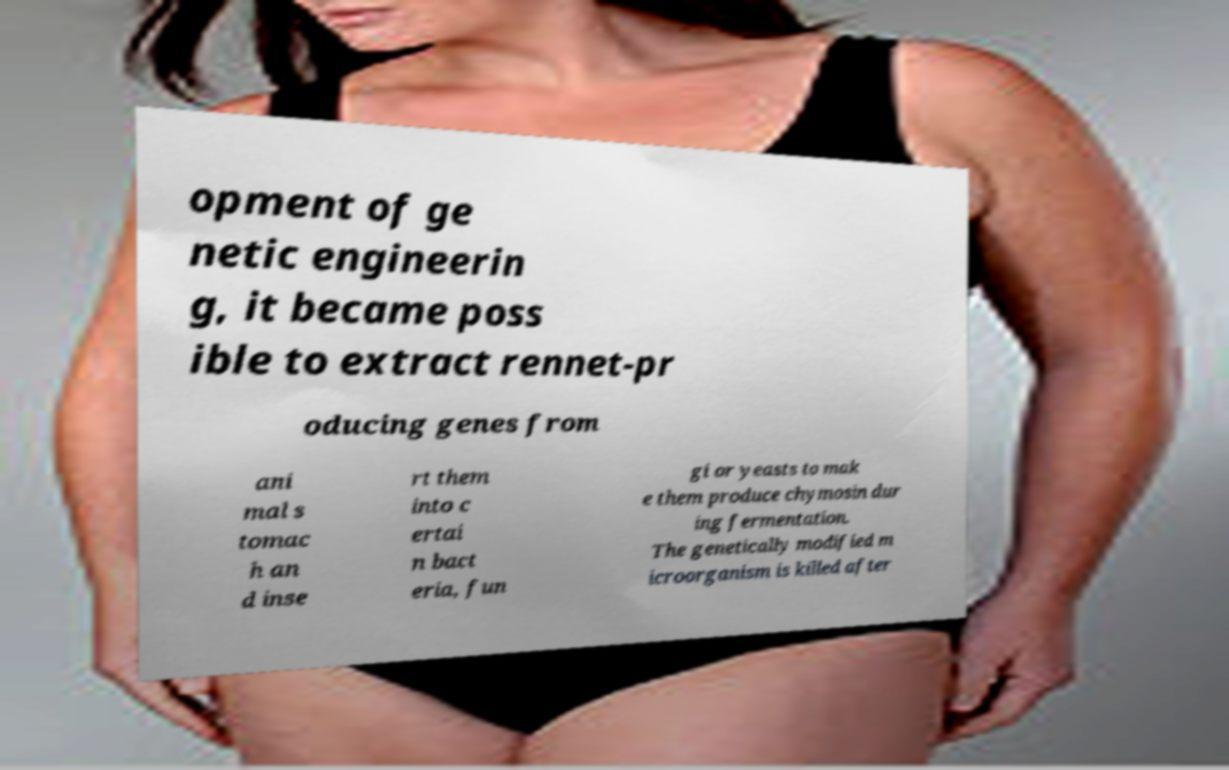I need the written content from this picture converted into text. Can you do that? opment of ge netic engineerin g, it became poss ible to extract rennet-pr oducing genes from ani mal s tomac h an d inse rt them into c ertai n bact eria, fun gi or yeasts to mak e them produce chymosin dur ing fermentation. The genetically modified m icroorganism is killed after 